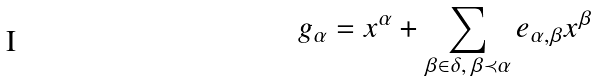<formula> <loc_0><loc_0><loc_500><loc_500>g _ { \alpha } = x ^ { \alpha } + \sum _ { \beta \in \delta , \, \beta \prec \alpha } e _ { \alpha , \beta } x ^ { \beta }</formula> 